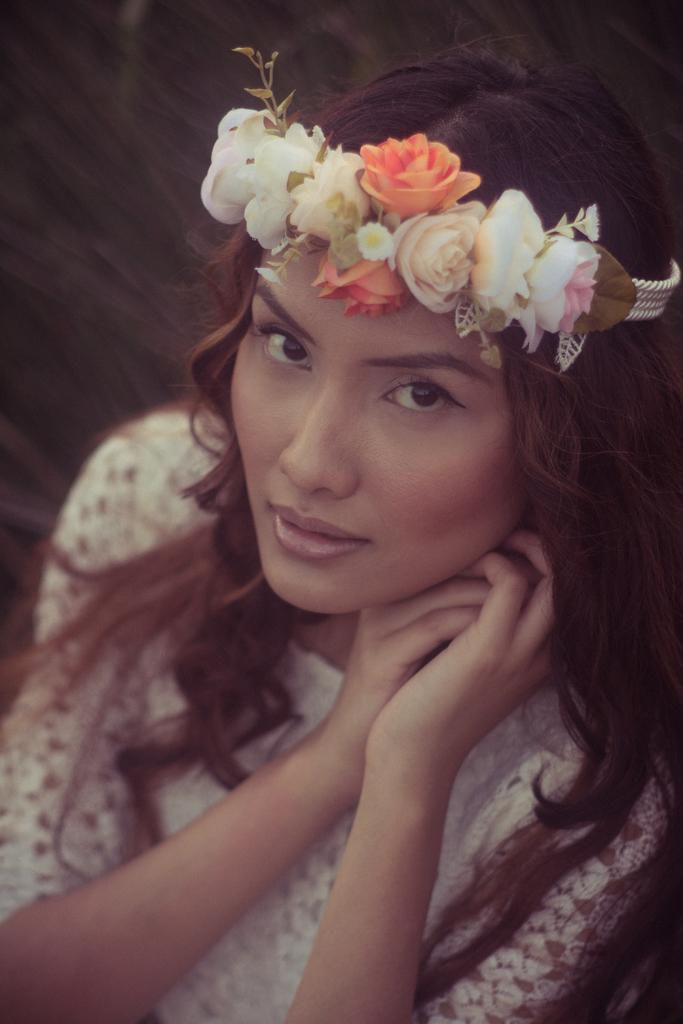Who is the main subject in the image? There is a lady in the image. What is the lady wearing? The lady is wearing a white dress and a flower crown. What type of horn can be seen on the lady's head in the image? There is no horn present on the lady's head in the image; she is wearing a flower crown. 